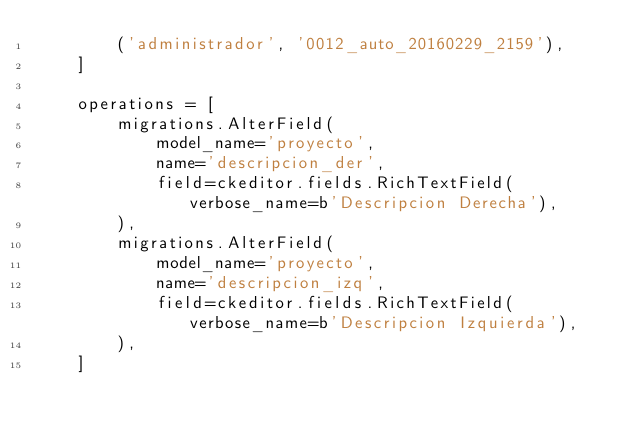Convert code to text. <code><loc_0><loc_0><loc_500><loc_500><_Python_>        ('administrador', '0012_auto_20160229_2159'),
    ]

    operations = [
        migrations.AlterField(
            model_name='proyecto',
            name='descripcion_der',
            field=ckeditor.fields.RichTextField(verbose_name=b'Descripcion Derecha'),
        ),
        migrations.AlterField(
            model_name='proyecto',
            name='descripcion_izq',
            field=ckeditor.fields.RichTextField(verbose_name=b'Descripcion Izquierda'),
        ),
    ]
</code> 